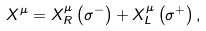<formula> <loc_0><loc_0><loc_500><loc_500>X ^ { \mu } = X _ { R } ^ { \mu } \left ( \sigma ^ { - } \right ) + X _ { L } ^ { \mu } \left ( \sigma ^ { + } \right ) ,</formula> 